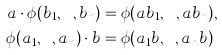Convert formula to latex. <formula><loc_0><loc_0><loc_500><loc_500>a \cdot \phi ( b _ { 1 } , \cdots , b _ { n } ) & = \phi ( a b _ { 1 } , \cdots , a b _ { n } ) , \\ \phi ( a _ { 1 } , \cdots , a _ { n } ) \cdot b & = \phi ( a _ { 1 } b , \cdots , a _ { n } b )</formula> 